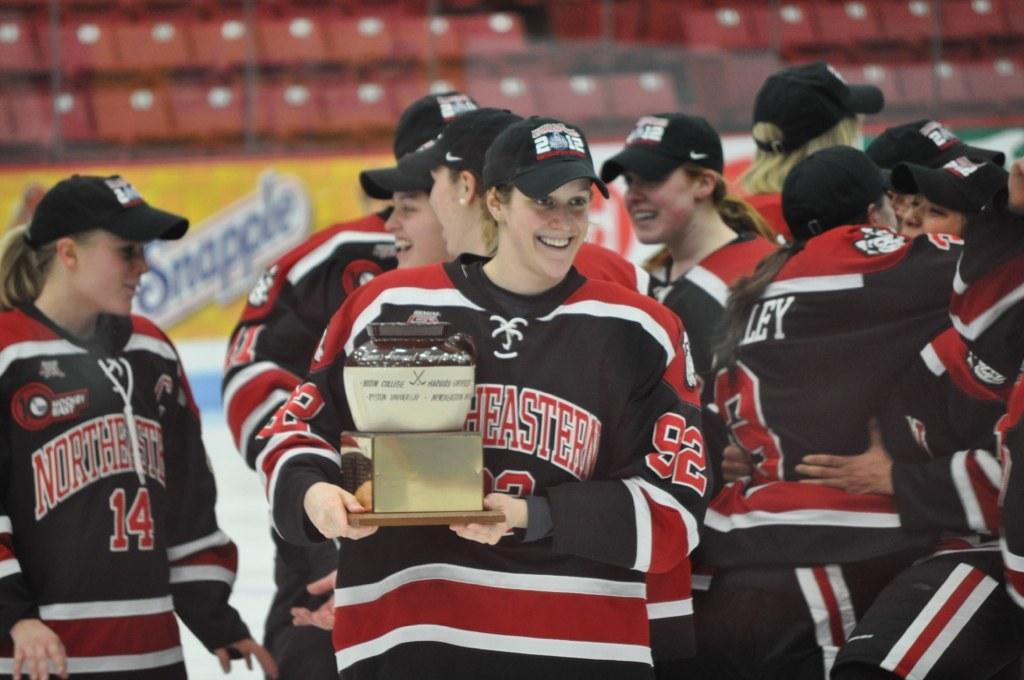What is the number of the player holding the trophy?
Make the answer very short. 92. 